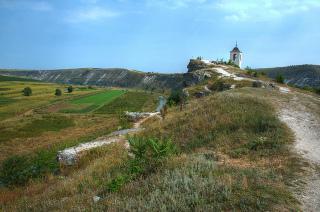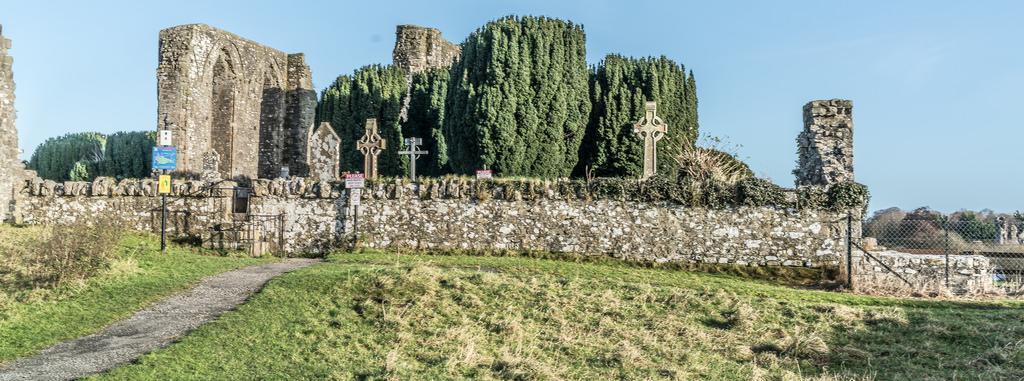The first image is the image on the left, the second image is the image on the right. Given the left and right images, does the statement "The building in one of the images is near a body of water." hold true? Answer yes or no. No. The first image is the image on the left, the second image is the image on the right. Given the left and right images, does the statement "The nearest end wall of ancient stone church ruins rises to a triangular point with a large window opening placed directly under the point." hold true? Answer yes or no. No. 